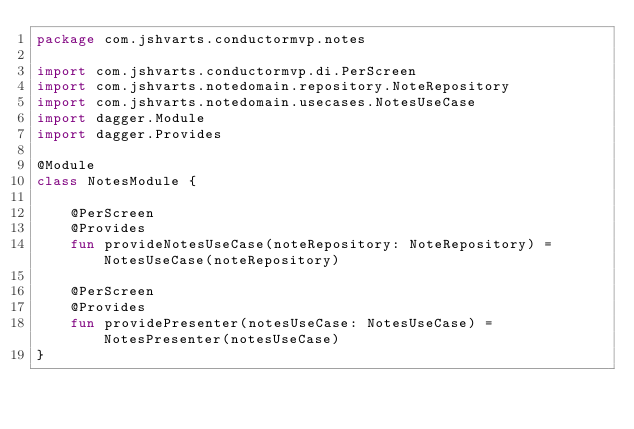Convert code to text. <code><loc_0><loc_0><loc_500><loc_500><_Kotlin_>package com.jshvarts.conductormvp.notes

import com.jshvarts.conductormvp.di.PerScreen
import com.jshvarts.notedomain.repository.NoteRepository
import com.jshvarts.notedomain.usecases.NotesUseCase
import dagger.Module
import dagger.Provides

@Module
class NotesModule {

    @PerScreen
    @Provides
    fun provideNotesUseCase(noteRepository: NoteRepository) = NotesUseCase(noteRepository)

    @PerScreen
    @Provides
    fun providePresenter(notesUseCase: NotesUseCase) = NotesPresenter(notesUseCase)
}</code> 